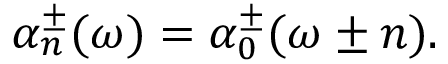<formula> <loc_0><loc_0><loc_500><loc_500>\alpha _ { n } ^ { \pm } ( \omega ) = \alpha _ { 0 } ^ { \pm } ( \omega \pm n ) .</formula> 